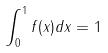Convert formula to latex. <formula><loc_0><loc_0><loc_500><loc_500>\int _ { 0 } ^ { 1 } f ( x ) d x = 1</formula> 